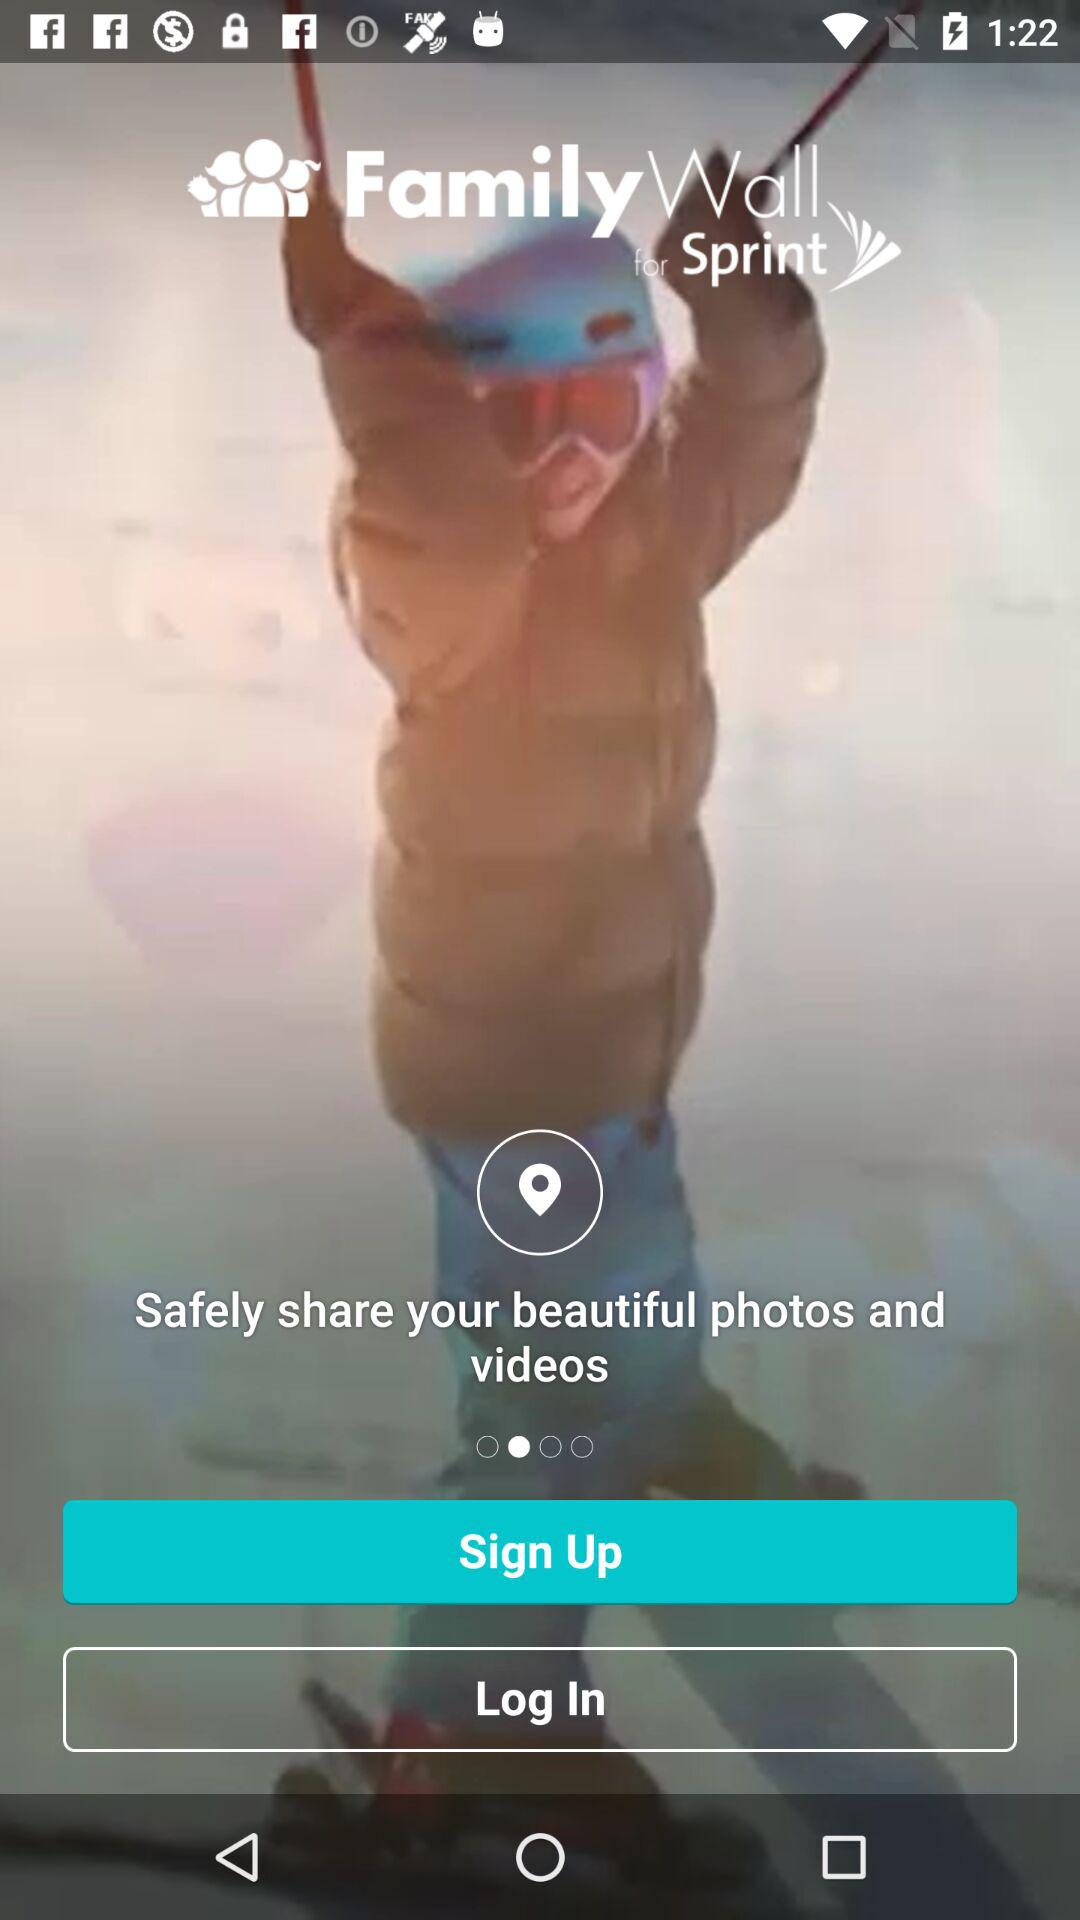What is the application name? The application name is "Family Wall for Sprint". 